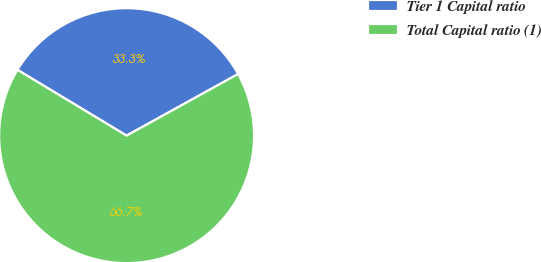Convert chart to OTSL. <chart><loc_0><loc_0><loc_500><loc_500><pie_chart><fcel>Tier 1 Capital ratio<fcel>Total Capital ratio (1)<nl><fcel>33.33%<fcel>66.67%<nl></chart> 